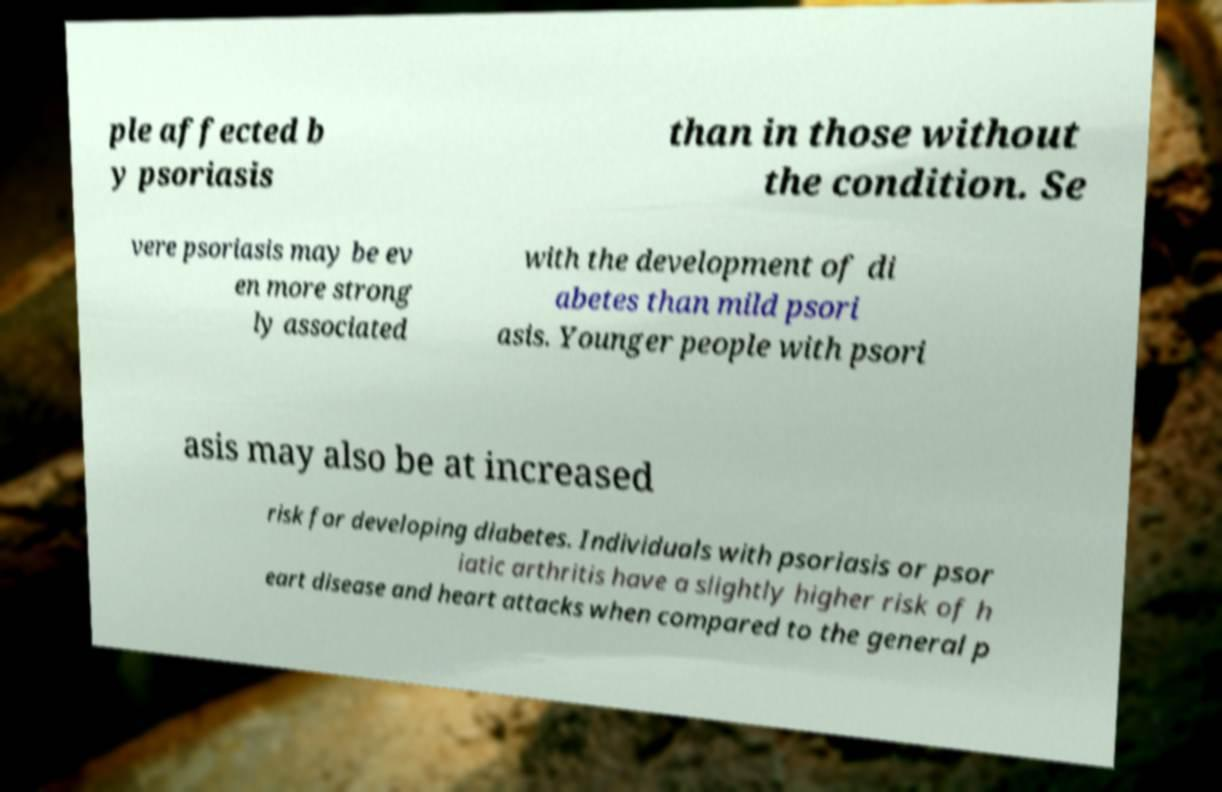What messages or text are displayed in this image? I need them in a readable, typed format. ple affected b y psoriasis than in those without the condition. Se vere psoriasis may be ev en more strong ly associated with the development of di abetes than mild psori asis. Younger people with psori asis may also be at increased risk for developing diabetes. Individuals with psoriasis or psor iatic arthritis have a slightly higher risk of h eart disease and heart attacks when compared to the general p 